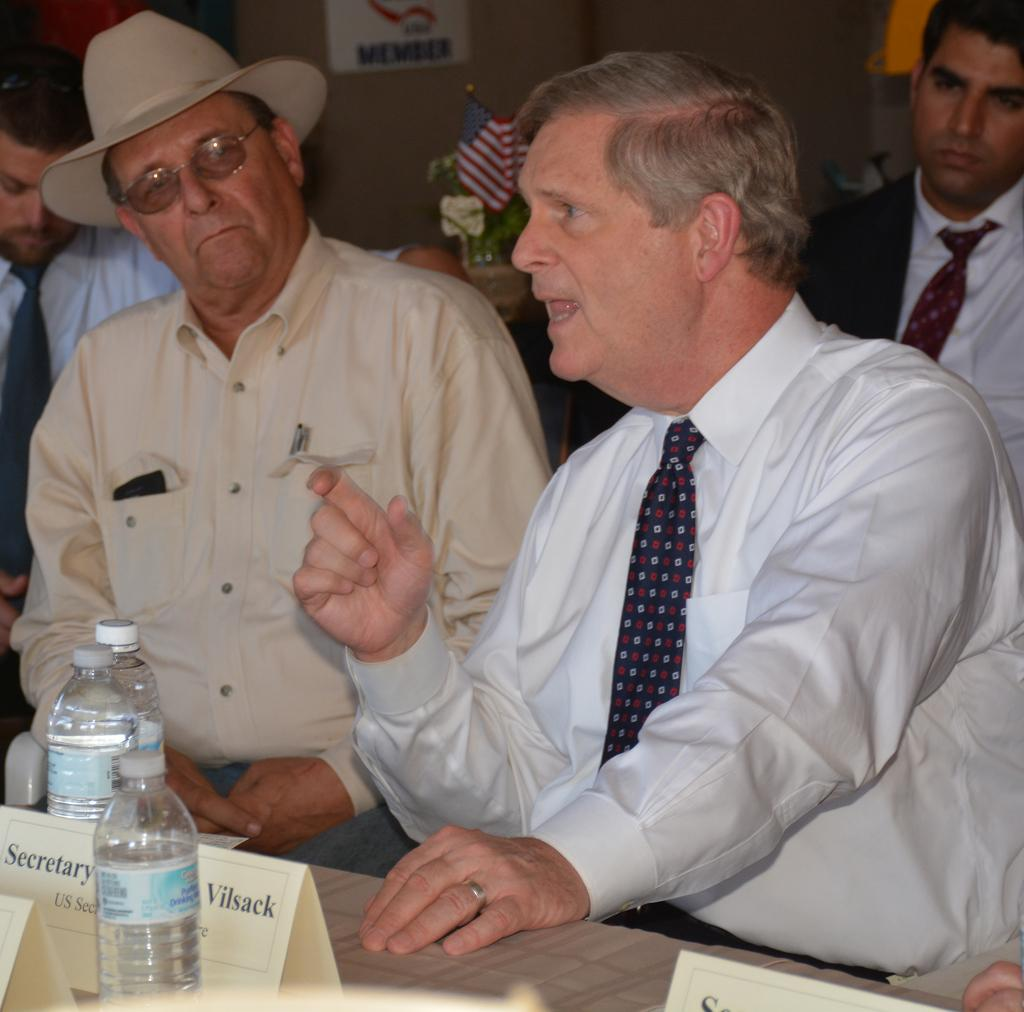How many people are in the image? There is a group of people in the image. What are the people doing in the image? The people are sitting on chairs. What is on the table in the image? There is a bottle and a name board on the table. What can be seen in the background of the image? There is a flag and a poster in the background of the image. How many sisters are whistling for wealth in the image? There is no mention of sisters, whistling, or wealth in the image. The image features a group of people sitting on chairs with a table, a bottle, a name board, a flag, and a poster in the background. 